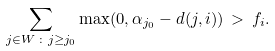Convert formula to latex. <formula><loc_0><loc_0><loc_500><loc_500>\sum _ { j \in W \, \colon j \geq j _ { 0 } } \max ( 0 , \alpha _ { j _ { 0 } } - d ( j , i ) ) \, > \, f _ { i } .</formula> 